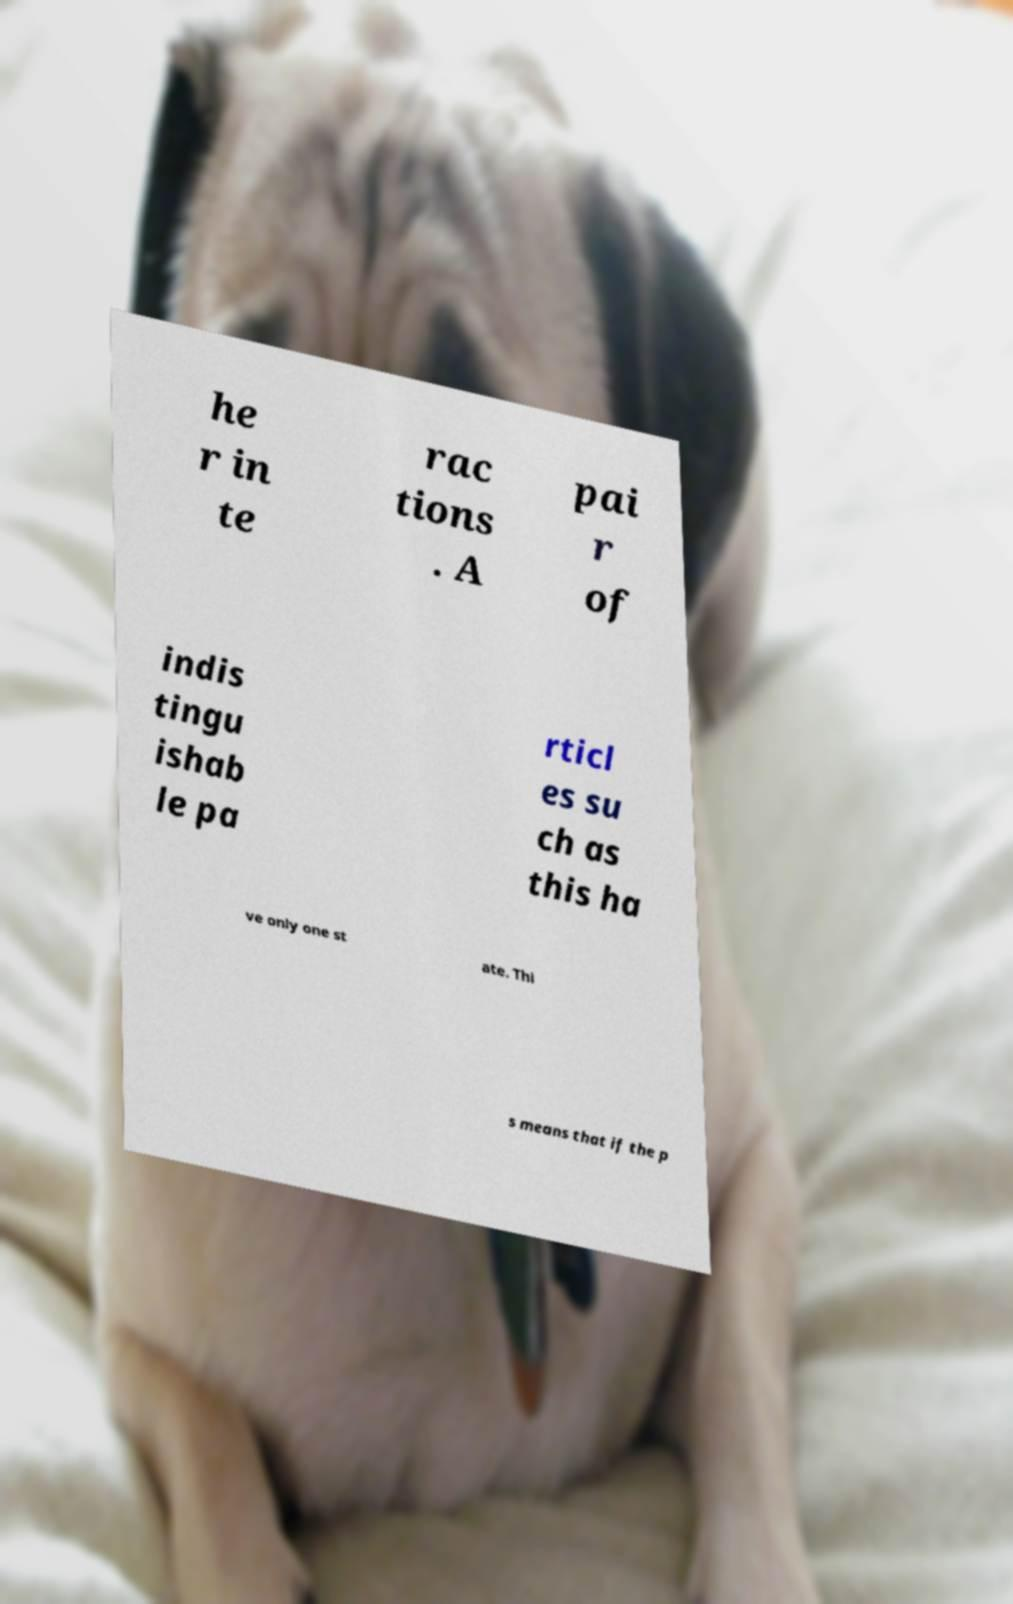Can you accurately transcribe the text from the provided image for me? he r in te rac tions . A pai r of indis tingu ishab le pa rticl es su ch as this ha ve only one st ate. Thi s means that if the p 